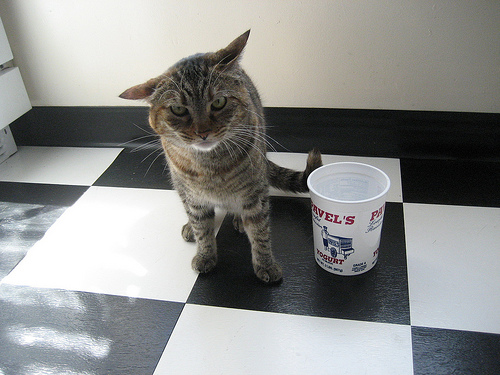<image>
Is the cat to the left of the container? Yes. From this viewpoint, the cat is positioned to the left side relative to the container. Where is the cat in relation to the cup? Is it to the left of the cup? Yes. From this viewpoint, the cat is positioned to the left side relative to the cup. Is there a bowl in front of the cat? No. The bowl is not in front of the cat. The spatial positioning shows a different relationship between these objects. 